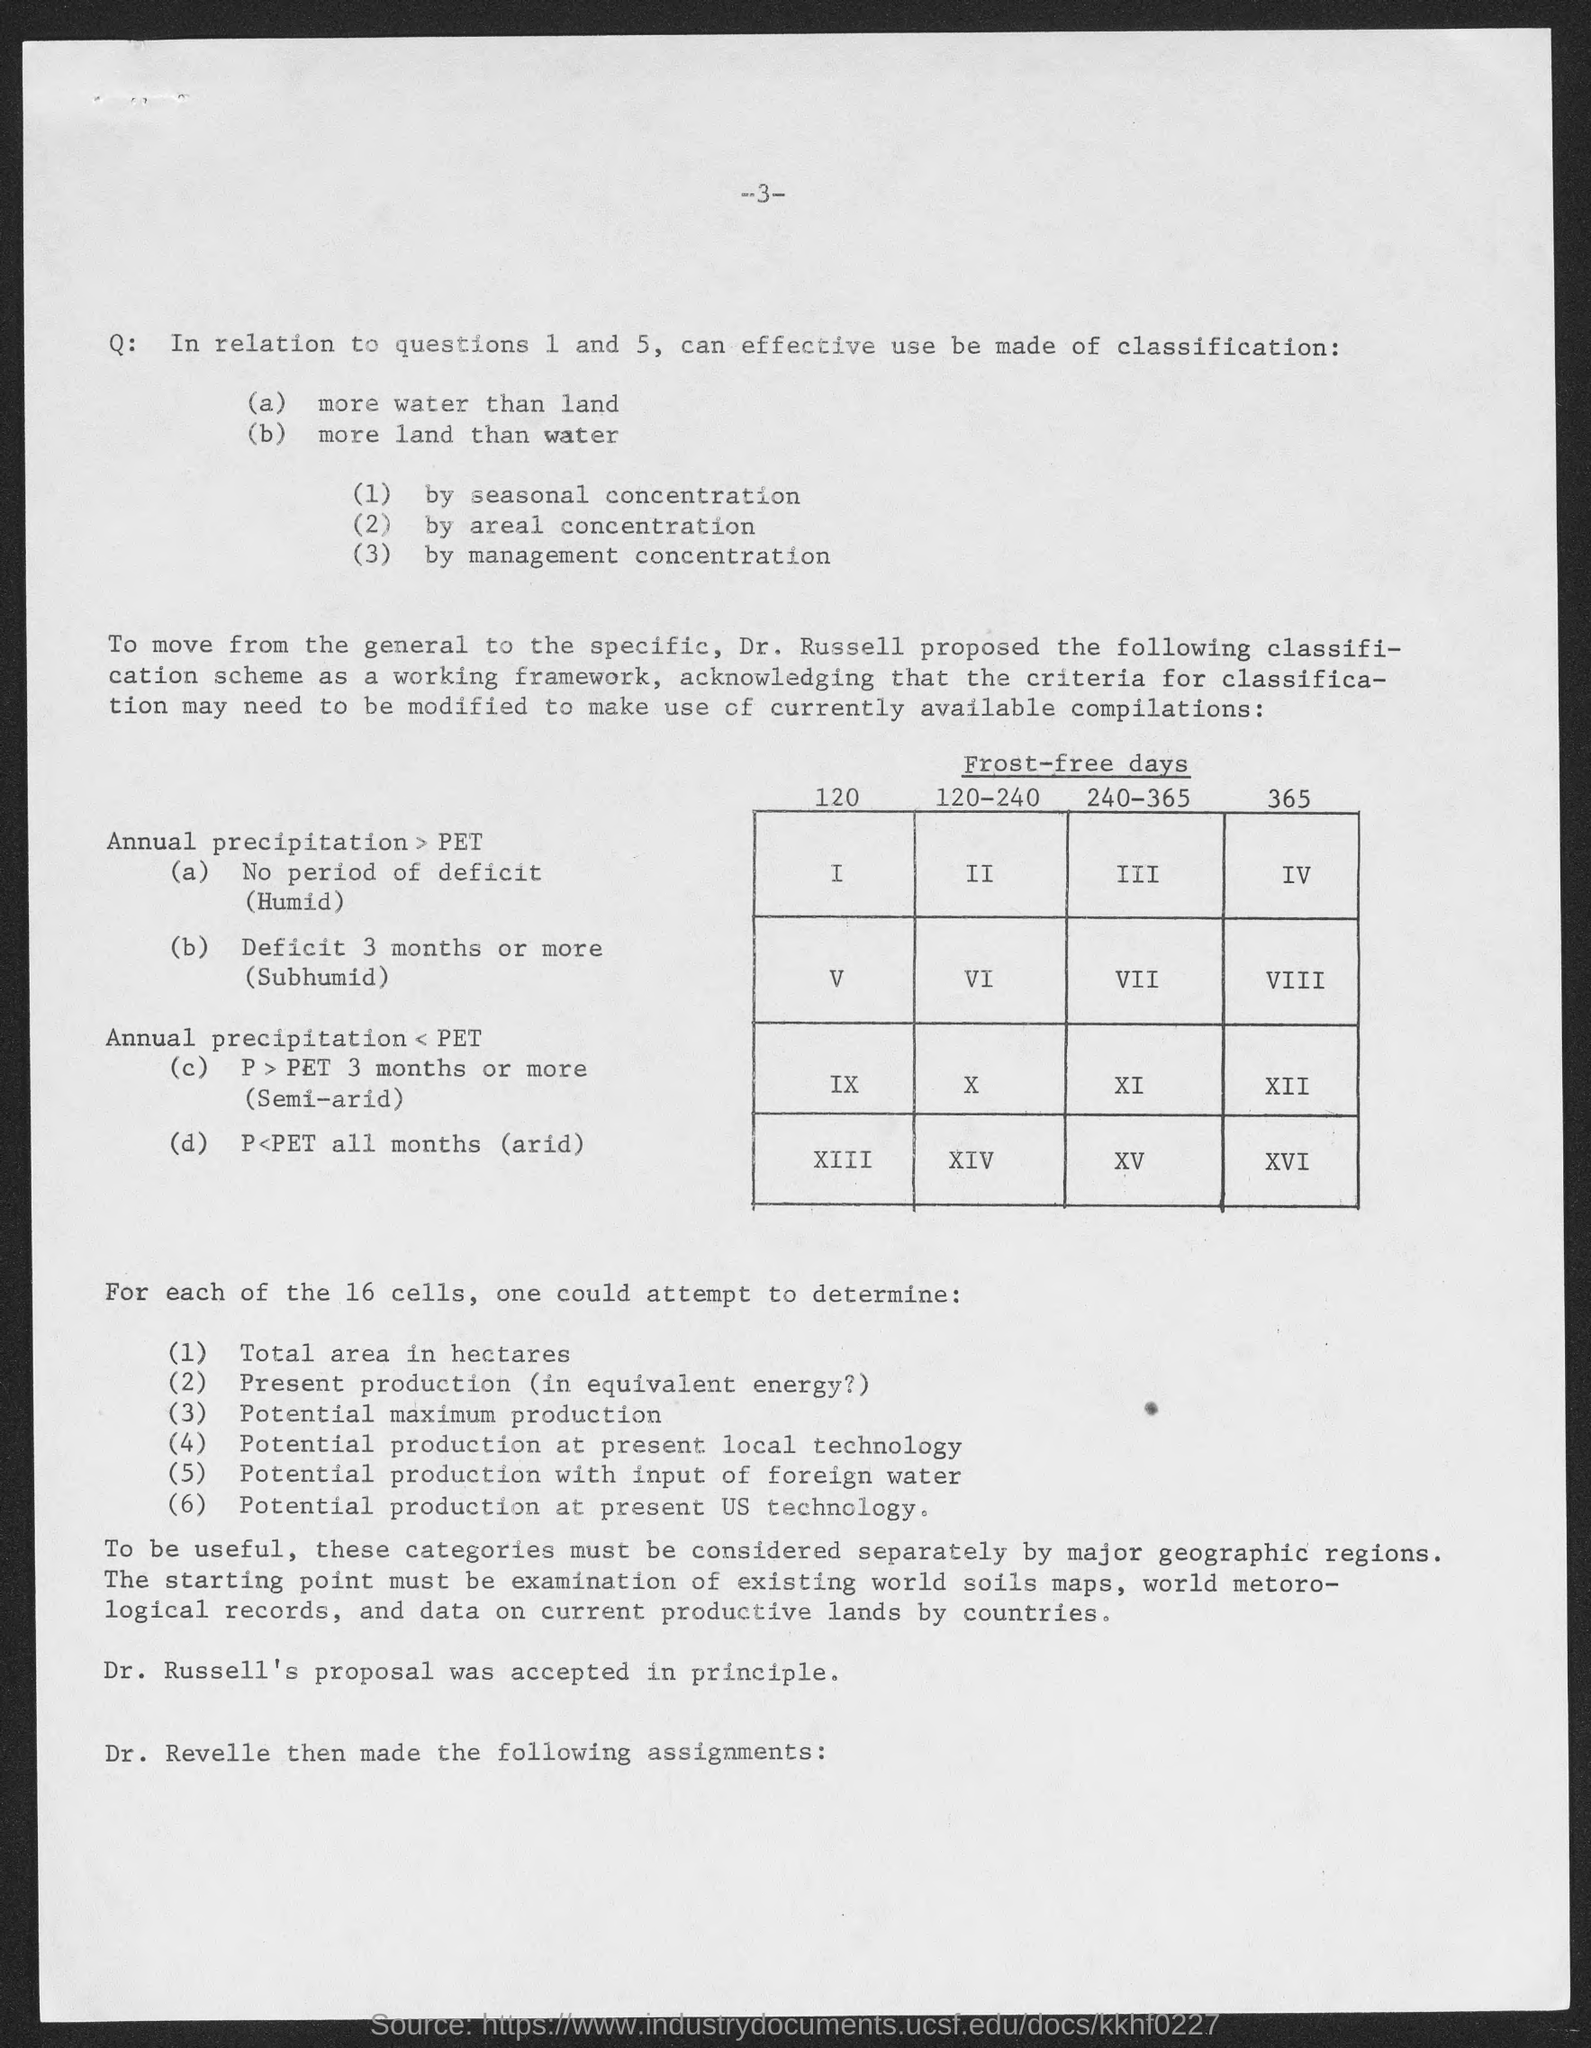What is the title of table?
Provide a short and direct response. Frost-Free days. 